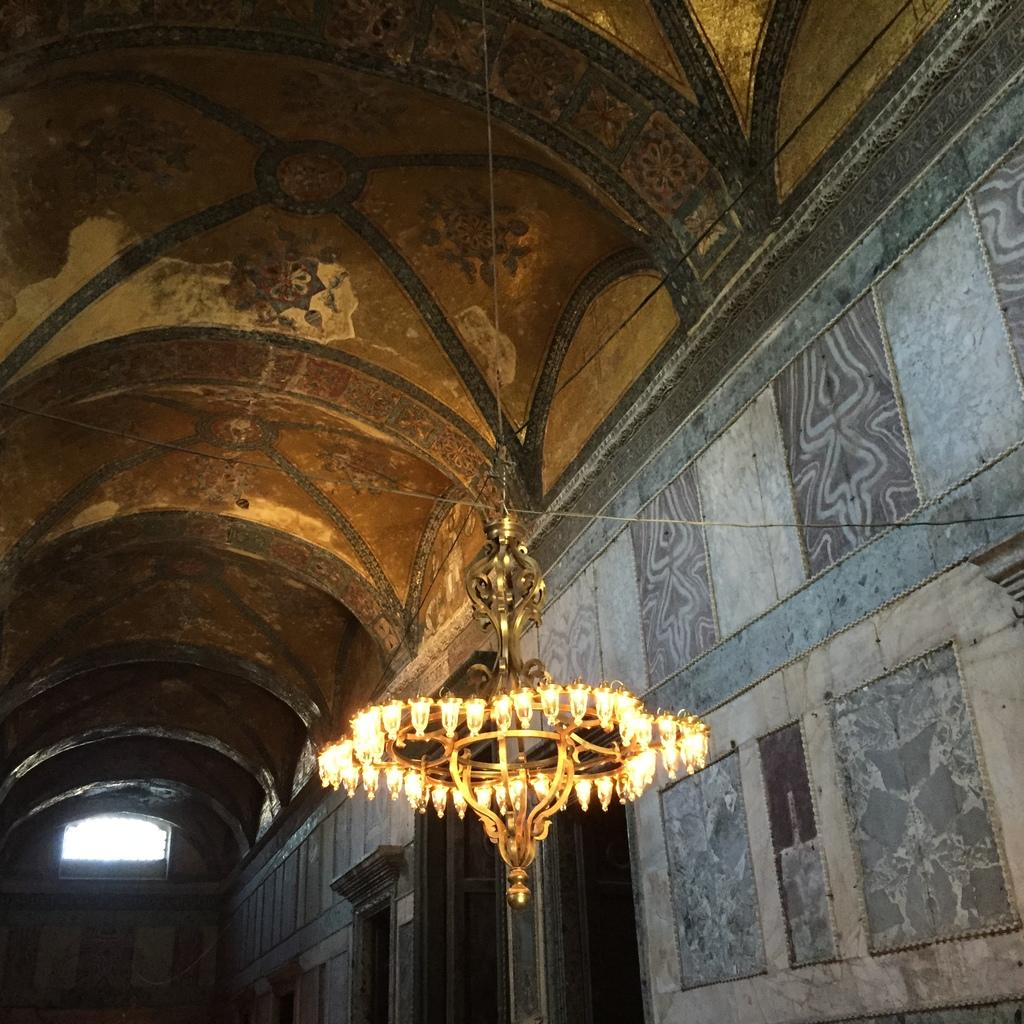What is the main object in the foreground of the image? There is a chandelier in the foreground of the image. What architectural feature can be seen at the bottom side of the image? There are doors at the bottom side of the image. What part of a building is visible at the top side of the image? There is a roof visible at the top side of the image. Can you tell me how many beetles are crawling on the chandelier in the image? There are no beetles present on the chandelier in the image. What type of order is being followed by the doors at the bottom side of the image? The doors do not follow any specific order; they are simply visible in the image. 